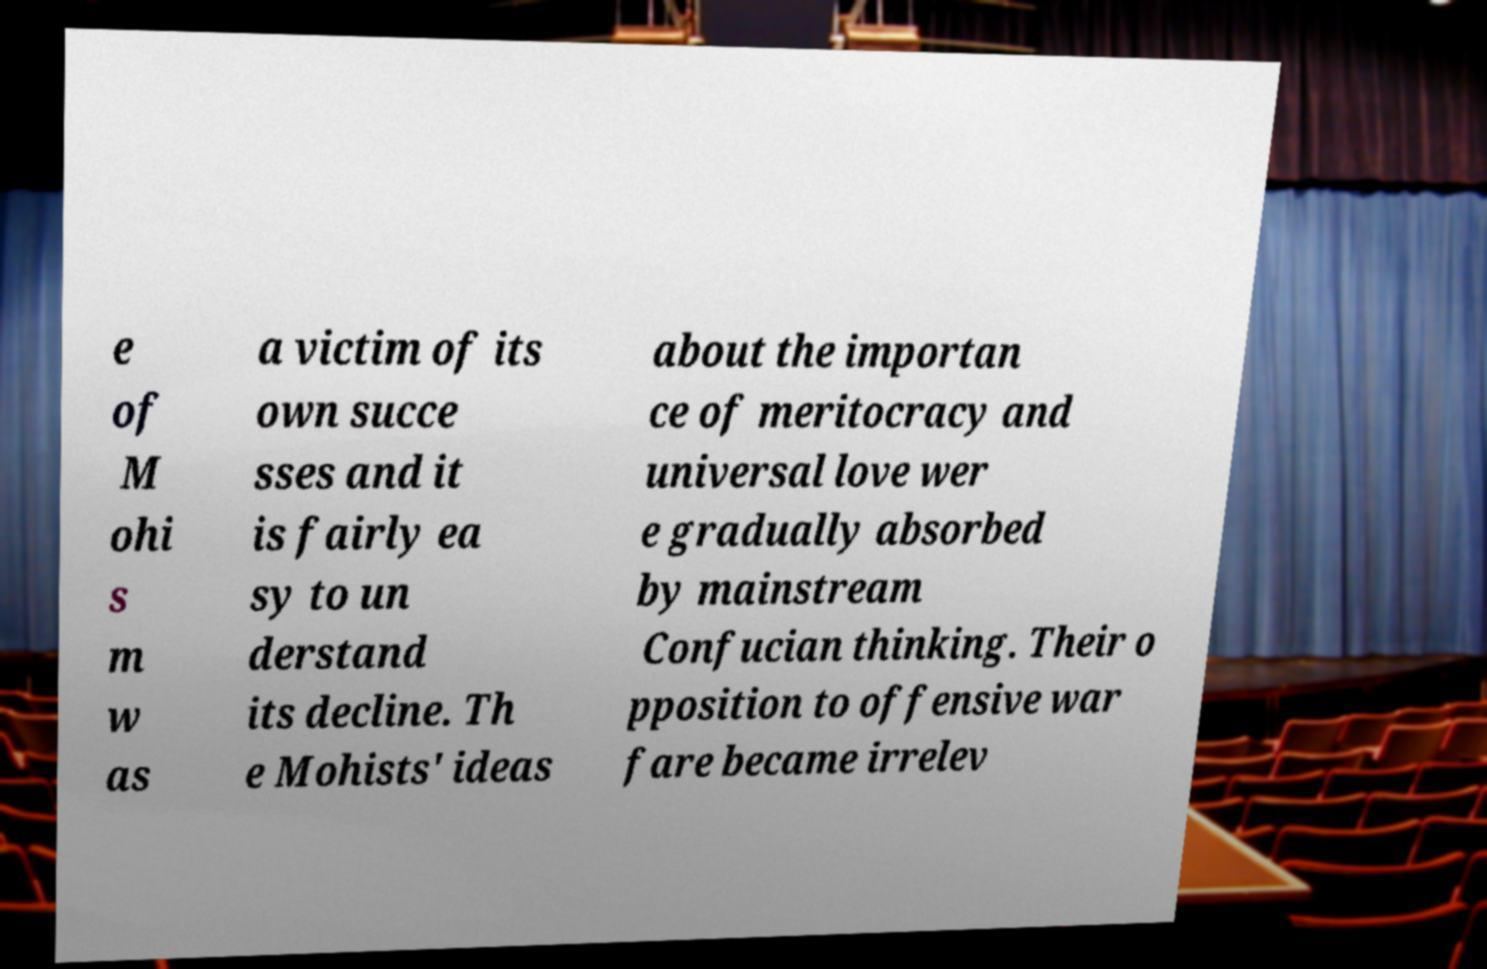Could you extract and type out the text from this image? e of M ohi s m w as a victim of its own succe sses and it is fairly ea sy to un derstand its decline. Th e Mohists' ideas about the importan ce of meritocracy and universal love wer e gradually absorbed by mainstream Confucian thinking. Their o pposition to offensive war fare became irrelev 